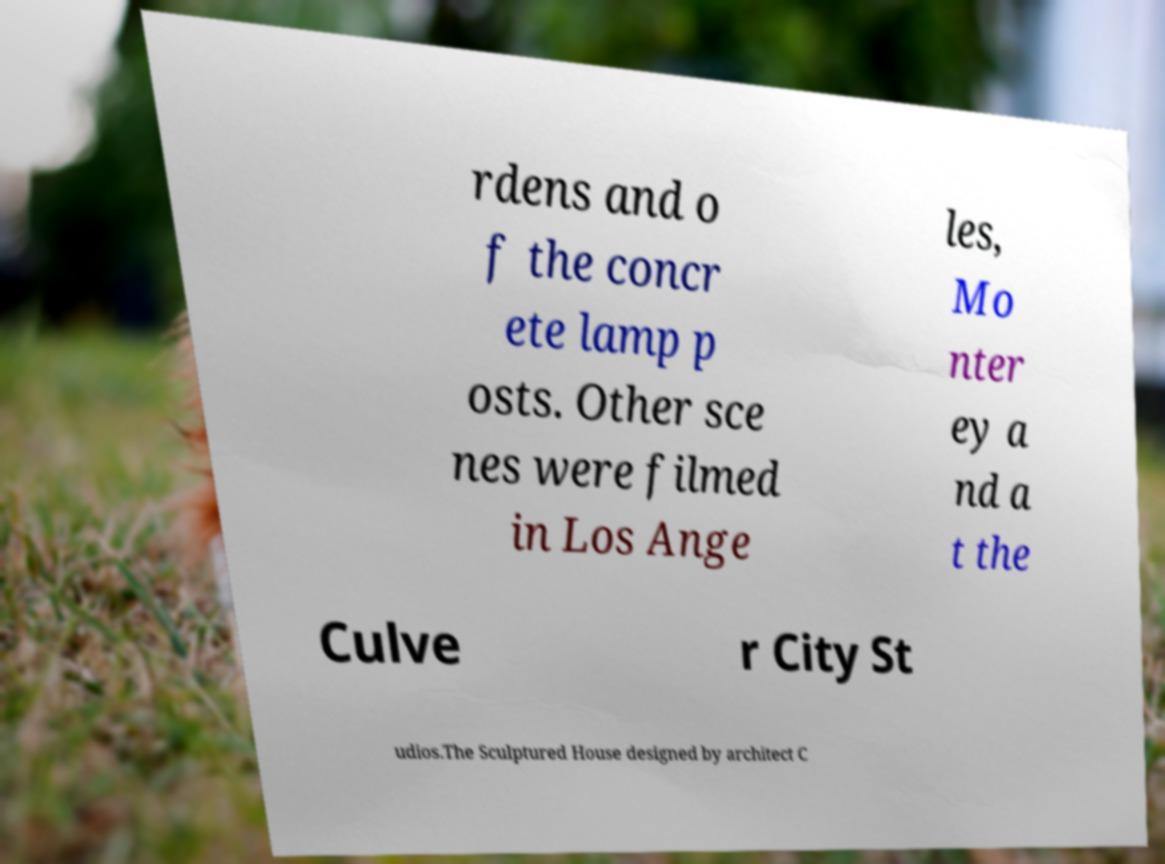Can you read and provide the text displayed in the image?This photo seems to have some interesting text. Can you extract and type it out for me? rdens and o f the concr ete lamp p osts. Other sce nes were filmed in Los Ange les, Mo nter ey a nd a t the Culve r City St udios.The Sculptured House designed by architect C 